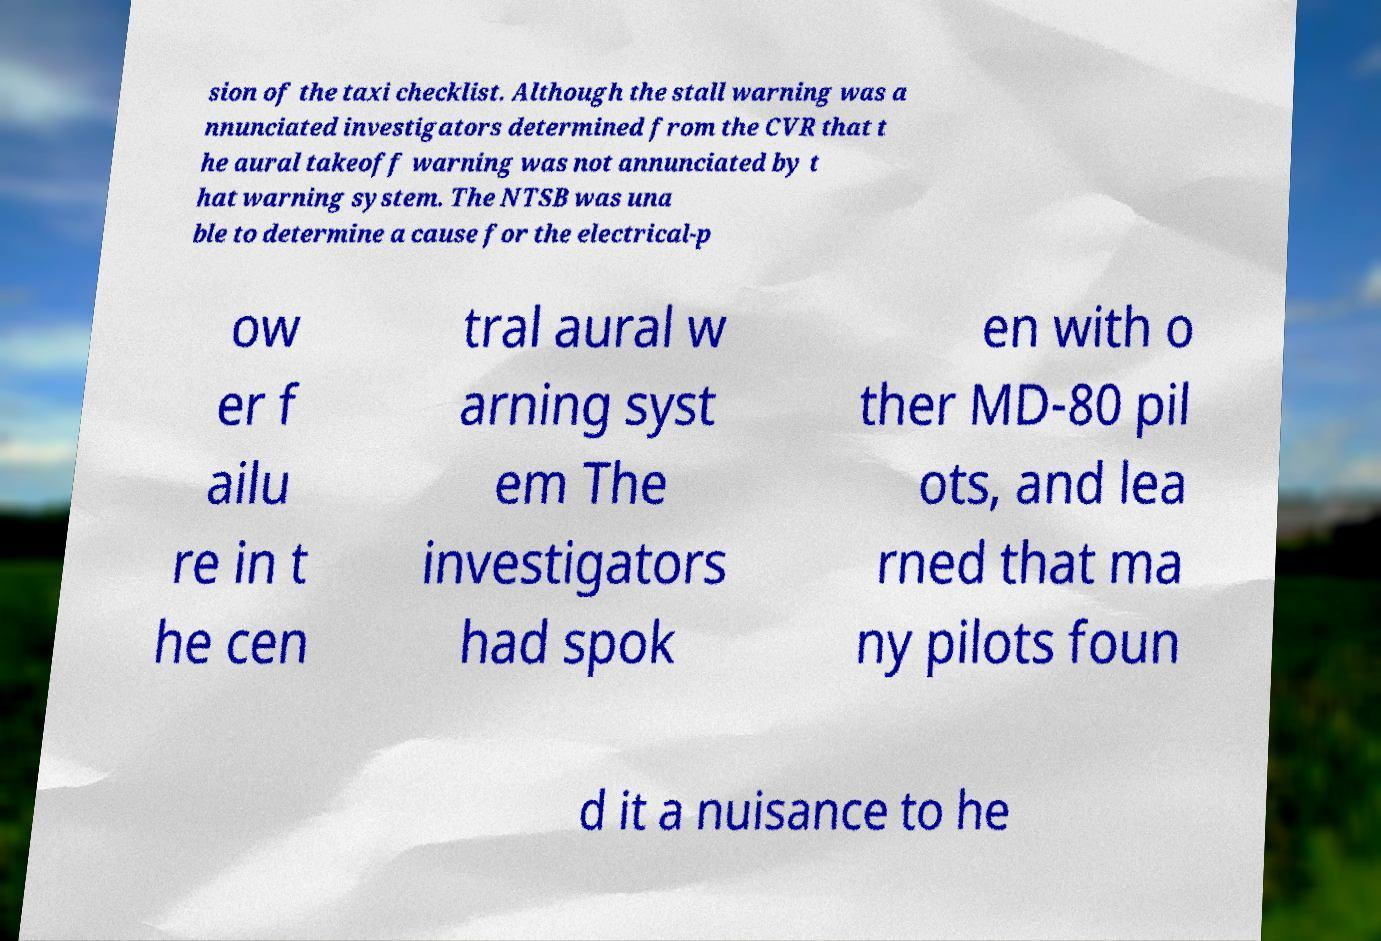Can you accurately transcribe the text from the provided image for me? sion of the taxi checklist. Although the stall warning was a nnunciated investigators determined from the CVR that t he aural takeoff warning was not annunciated by t hat warning system. The NTSB was una ble to determine a cause for the electrical-p ow er f ailu re in t he cen tral aural w arning syst em The investigators had spok en with o ther MD-80 pil ots, and lea rned that ma ny pilots foun d it a nuisance to he 